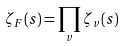Convert formula to latex. <formula><loc_0><loc_0><loc_500><loc_500>\zeta _ { F } ( s ) = \prod _ { v } \zeta _ { v } ( s )</formula> 